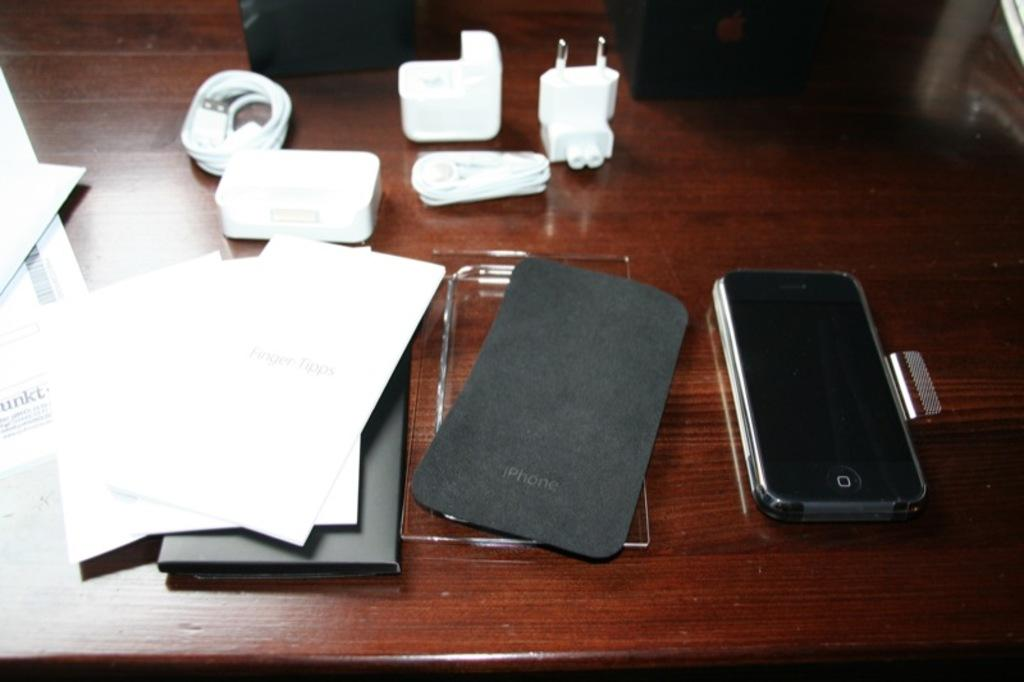<image>
Write a terse but informative summary of the picture. An iPhone is unpackaged on a wooden desk. 